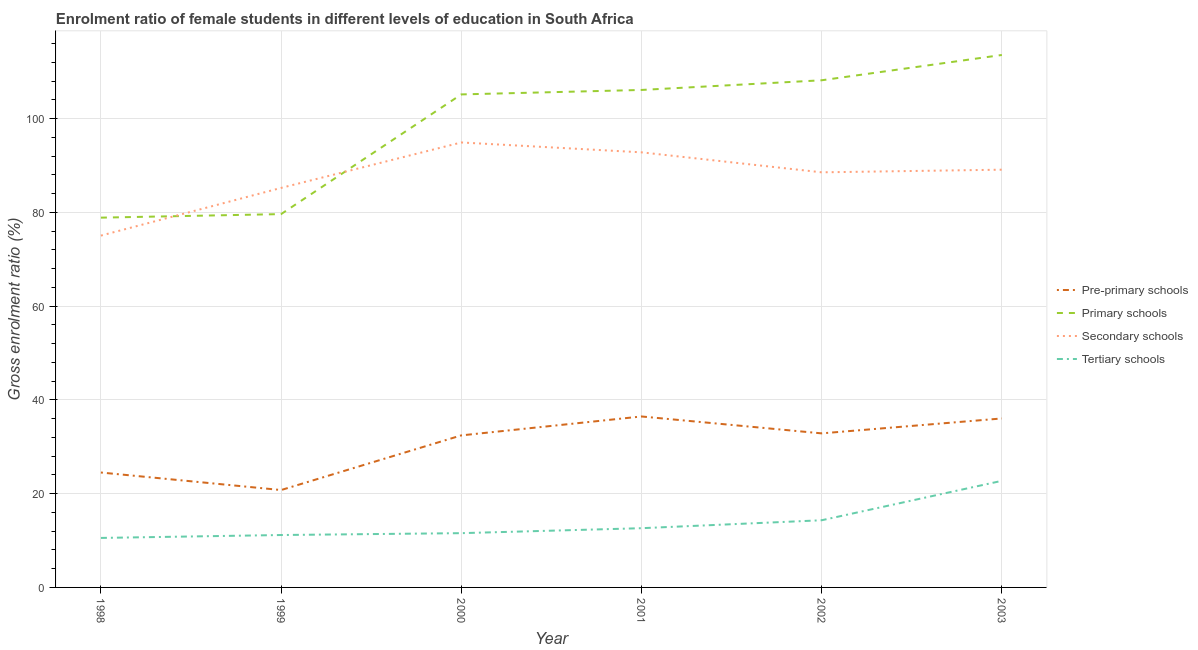How many different coloured lines are there?
Provide a short and direct response. 4. Does the line corresponding to gross enrolment ratio(male) in tertiary schools intersect with the line corresponding to gross enrolment ratio(male) in primary schools?
Give a very brief answer. No. Is the number of lines equal to the number of legend labels?
Provide a succinct answer. Yes. What is the gross enrolment ratio(male) in secondary schools in 2001?
Your answer should be very brief. 92.82. Across all years, what is the maximum gross enrolment ratio(male) in primary schools?
Your answer should be compact. 113.59. Across all years, what is the minimum gross enrolment ratio(male) in secondary schools?
Ensure brevity in your answer.  75.06. What is the total gross enrolment ratio(male) in pre-primary schools in the graph?
Keep it short and to the point. 183.11. What is the difference between the gross enrolment ratio(male) in tertiary schools in 1999 and that in 2001?
Keep it short and to the point. -1.46. What is the difference between the gross enrolment ratio(male) in secondary schools in 2002 and the gross enrolment ratio(male) in primary schools in 2003?
Your response must be concise. -25.04. What is the average gross enrolment ratio(male) in pre-primary schools per year?
Your response must be concise. 30.52. In the year 2002, what is the difference between the gross enrolment ratio(male) in secondary schools and gross enrolment ratio(male) in tertiary schools?
Offer a very short reply. 74.23. In how many years, is the gross enrolment ratio(male) in primary schools greater than 112 %?
Give a very brief answer. 1. What is the ratio of the gross enrolment ratio(male) in tertiary schools in 1998 to that in 2001?
Provide a succinct answer. 0.84. Is the gross enrolment ratio(male) in tertiary schools in 1998 less than that in 2000?
Ensure brevity in your answer.  Yes. Is the difference between the gross enrolment ratio(male) in pre-primary schools in 1999 and 2003 greater than the difference between the gross enrolment ratio(male) in secondary schools in 1999 and 2003?
Your answer should be very brief. No. What is the difference between the highest and the second highest gross enrolment ratio(male) in tertiary schools?
Offer a very short reply. 8.41. What is the difference between the highest and the lowest gross enrolment ratio(male) in pre-primary schools?
Give a very brief answer. 15.7. In how many years, is the gross enrolment ratio(male) in tertiary schools greater than the average gross enrolment ratio(male) in tertiary schools taken over all years?
Provide a short and direct response. 2. Does the gross enrolment ratio(male) in pre-primary schools monotonically increase over the years?
Offer a very short reply. No. Is the gross enrolment ratio(male) in pre-primary schools strictly less than the gross enrolment ratio(male) in secondary schools over the years?
Offer a terse response. Yes. How many lines are there?
Offer a very short reply. 4. Are the values on the major ticks of Y-axis written in scientific E-notation?
Make the answer very short. No. Does the graph contain grids?
Your response must be concise. Yes. Where does the legend appear in the graph?
Offer a terse response. Center right. How many legend labels are there?
Your answer should be very brief. 4. How are the legend labels stacked?
Your response must be concise. Vertical. What is the title of the graph?
Ensure brevity in your answer.  Enrolment ratio of female students in different levels of education in South Africa. What is the label or title of the X-axis?
Offer a very short reply. Year. What is the label or title of the Y-axis?
Ensure brevity in your answer.  Gross enrolment ratio (%). What is the Gross enrolment ratio (%) in Pre-primary schools in 1998?
Keep it short and to the point. 24.51. What is the Gross enrolment ratio (%) in Primary schools in 1998?
Make the answer very short. 78.89. What is the Gross enrolment ratio (%) of Secondary schools in 1998?
Offer a terse response. 75.06. What is the Gross enrolment ratio (%) of Tertiary schools in 1998?
Offer a very short reply. 10.56. What is the Gross enrolment ratio (%) of Pre-primary schools in 1999?
Give a very brief answer. 20.78. What is the Gross enrolment ratio (%) of Primary schools in 1999?
Ensure brevity in your answer.  79.64. What is the Gross enrolment ratio (%) in Secondary schools in 1999?
Your answer should be compact. 85.23. What is the Gross enrolment ratio (%) in Tertiary schools in 1999?
Offer a very short reply. 11.18. What is the Gross enrolment ratio (%) in Pre-primary schools in 2000?
Offer a terse response. 32.44. What is the Gross enrolment ratio (%) of Primary schools in 2000?
Make the answer very short. 105.18. What is the Gross enrolment ratio (%) of Secondary schools in 2000?
Provide a succinct answer. 94.93. What is the Gross enrolment ratio (%) of Tertiary schools in 2000?
Give a very brief answer. 11.58. What is the Gross enrolment ratio (%) of Pre-primary schools in 2001?
Give a very brief answer. 36.47. What is the Gross enrolment ratio (%) of Primary schools in 2001?
Your answer should be compact. 106.13. What is the Gross enrolment ratio (%) in Secondary schools in 2001?
Make the answer very short. 92.82. What is the Gross enrolment ratio (%) of Tertiary schools in 2001?
Make the answer very short. 12.64. What is the Gross enrolment ratio (%) of Pre-primary schools in 2002?
Offer a terse response. 32.87. What is the Gross enrolment ratio (%) in Primary schools in 2002?
Your answer should be very brief. 108.19. What is the Gross enrolment ratio (%) in Secondary schools in 2002?
Your answer should be very brief. 88.56. What is the Gross enrolment ratio (%) in Tertiary schools in 2002?
Provide a short and direct response. 14.33. What is the Gross enrolment ratio (%) of Pre-primary schools in 2003?
Make the answer very short. 36.05. What is the Gross enrolment ratio (%) in Primary schools in 2003?
Offer a terse response. 113.59. What is the Gross enrolment ratio (%) in Secondary schools in 2003?
Your answer should be compact. 89.12. What is the Gross enrolment ratio (%) in Tertiary schools in 2003?
Make the answer very short. 22.74. Across all years, what is the maximum Gross enrolment ratio (%) of Pre-primary schools?
Keep it short and to the point. 36.47. Across all years, what is the maximum Gross enrolment ratio (%) in Primary schools?
Offer a terse response. 113.59. Across all years, what is the maximum Gross enrolment ratio (%) in Secondary schools?
Ensure brevity in your answer.  94.93. Across all years, what is the maximum Gross enrolment ratio (%) in Tertiary schools?
Give a very brief answer. 22.74. Across all years, what is the minimum Gross enrolment ratio (%) of Pre-primary schools?
Offer a terse response. 20.78. Across all years, what is the minimum Gross enrolment ratio (%) in Primary schools?
Your answer should be compact. 78.89. Across all years, what is the minimum Gross enrolment ratio (%) in Secondary schools?
Make the answer very short. 75.06. Across all years, what is the minimum Gross enrolment ratio (%) of Tertiary schools?
Your answer should be compact. 10.56. What is the total Gross enrolment ratio (%) of Pre-primary schools in the graph?
Your answer should be very brief. 183.11. What is the total Gross enrolment ratio (%) in Primary schools in the graph?
Keep it short and to the point. 591.62. What is the total Gross enrolment ratio (%) of Secondary schools in the graph?
Give a very brief answer. 525.71. What is the total Gross enrolment ratio (%) in Tertiary schools in the graph?
Provide a short and direct response. 83.02. What is the difference between the Gross enrolment ratio (%) of Pre-primary schools in 1998 and that in 1999?
Your response must be concise. 3.74. What is the difference between the Gross enrolment ratio (%) in Primary schools in 1998 and that in 1999?
Offer a very short reply. -0.76. What is the difference between the Gross enrolment ratio (%) of Secondary schools in 1998 and that in 1999?
Provide a succinct answer. -10.17. What is the difference between the Gross enrolment ratio (%) in Tertiary schools in 1998 and that in 1999?
Give a very brief answer. -0.62. What is the difference between the Gross enrolment ratio (%) of Pre-primary schools in 1998 and that in 2000?
Keep it short and to the point. -7.92. What is the difference between the Gross enrolment ratio (%) of Primary schools in 1998 and that in 2000?
Give a very brief answer. -26.29. What is the difference between the Gross enrolment ratio (%) in Secondary schools in 1998 and that in 2000?
Your answer should be very brief. -19.87. What is the difference between the Gross enrolment ratio (%) of Tertiary schools in 1998 and that in 2000?
Make the answer very short. -1.02. What is the difference between the Gross enrolment ratio (%) of Pre-primary schools in 1998 and that in 2001?
Make the answer very short. -11.96. What is the difference between the Gross enrolment ratio (%) in Primary schools in 1998 and that in 2001?
Make the answer very short. -27.24. What is the difference between the Gross enrolment ratio (%) in Secondary schools in 1998 and that in 2001?
Your response must be concise. -17.76. What is the difference between the Gross enrolment ratio (%) in Tertiary schools in 1998 and that in 2001?
Your response must be concise. -2.08. What is the difference between the Gross enrolment ratio (%) in Pre-primary schools in 1998 and that in 2002?
Provide a succinct answer. -8.35. What is the difference between the Gross enrolment ratio (%) in Primary schools in 1998 and that in 2002?
Offer a terse response. -29.31. What is the difference between the Gross enrolment ratio (%) in Secondary schools in 1998 and that in 2002?
Offer a very short reply. -13.5. What is the difference between the Gross enrolment ratio (%) of Tertiary schools in 1998 and that in 2002?
Provide a short and direct response. -3.77. What is the difference between the Gross enrolment ratio (%) in Pre-primary schools in 1998 and that in 2003?
Your answer should be very brief. -11.53. What is the difference between the Gross enrolment ratio (%) of Primary schools in 1998 and that in 2003?
Offer a terse response. -34.7. What is the difference between the Gross enrolment ratio (%) of Secondary schools in 1998 and that in 2003?
Ensure brevity in your answer.  -14.06. What is the difference between the Gross enrolment ratio (%) in Tertiary schools in 1998 and that in 2003?
Your answer should be compact. -12.18. What is the difference between the Gross enrolment ratio (%) of Pre-primary schools in 1999 and that in 2000?
Keep it short and to the point. -11.66. What is the difference between the Gross enrolment ratio (%) in Primary schools in 1999 and that in 2000?
Your answer should be compact. -25.53. What is the difference between the Gross enrolment ratio (%) of Secondary schools in 1999 and that in 2000?
Your answer should be compact. -9.69. What is the difference between the Gross enrolment ratio (%) of Tertiary schools in 1999 and that in 2000?
Keep it short and to the point. -0.4. What is the difference between the Gross enrolment ratio (%) in Pre-primary schools in 1999 and that in 2001?
Provide a succinct answer. -15.7. What is the difference between the Gross enrolment ratio (%) of Primary schools in 1999 and that in 2001?
Your answer should be very brief. -26.49. What is the difference between the Gross enrolment ratio (%) in Secondary schools in 1999 and that in 2001?
Your answer should be very brief. -7.59. What is the difference between the Gross enrolment ratio (%) of Tertiary schools in 1999 and that in 2001?
Offer a terse response. -1.46. What is the difference between the Gross enrolment ratio (%) of Pre-primary schools in 1999 and that in 2002?
Keep it short and to the point. -12.09. What is the difference between the Gross enrolment ratio (%) of Primary schools in 1999 and that in 2002?
Provide a succinct answer. -28.55. What is the difference between the Gross enrolment ratio (%) in Secondary schools in 1999 and that in 2002?
Ensure brevity in your answer.  -3.32. What is the difference between the Gross enrolment ratio (%) in Tertiary schools in 1999 and that in 2002?
Your answer should be compact. -3.15. What is the difference between the Gross enrolment ratio (%) of Pre-primary schools in 1999 and that in 2003?
Give a very brief answer. -15.27. What is the difference between the Gross enrolment ratio (%) in Primary schools in 1999 and that in 2003?
Your answer should be compact. -33.95. What is the difference between the Gross enrolment ratio (%) of Secondary schools in 1999 and that in 2003?
Provide a succinct answer. -3.89. What is the difference between the Gross enrolment ratio (%) of Tertiary schools in 1999 and that in 2003?
Ensure brevity in your answer.  -11.56. What is the difference between the Gross enrolment ratio (%) of Pre-primary schools in 2000 and that in 2001?
Give a very brief answer. -4.03. What is the difference between the Gross enrolment ratio (%) in Primary schools in 2000 and that in 2001?
Offer a terse response. -0.95. What is the difference between the Gross enrolment ratio (%) of Secondary schools in 2000 and that in 2001?
Your answer should be compact. 2.1. What is the difference between the Gross enrolment ratio (%) in Tertiary schools in 2000 and that in 2001?
Your answer should be very brief. -1.06. What is the difference between the Gross enrolment ratio (%) in Pre-primary schools in 2000 and that in 2002?
Your answer should be very brief. -0.43. What is the difference between the Gross enrolment ratio (%) of Primary schools in 2000 and that in 2002?
Offer a terse response. -3.02. What is the difference between the Gross enrolment ratio (%) of Secondary schools in 2000 and that in 2002?
Offer a terse response. 6.37. What is the difference between the Gross enrolment ratio (%) in Tertiary schools in 2000 and that in 2002?
Provide a succinct answer. -2.75. What is the difference between the Gross enrolment ratio (%) in Pre-primary schools in 2000 and that in 2003?
Your answer should be very brief. -3.61. What is the difference between the Gross enrolment ratio (%) of Primary schools in 2000 and that in 2003?
Your response must be concise. -8.41. What is the difference between the Gross enrolment ratio (%) of Secondary schools in 2000 and that in 2003?
Make the answer very short. 5.81. What is the difference between the Gross enrolment ratio (%) in Tertiary schools in 2000 and that in 2003?
Your answer should be compact. -11.16. What is the difference between the Gross enrolment ratio (%) of Pre-primary schools in 2001 and that in 2002?
Your answer should be compact. 3.61. What is the difference between the Gross enrolment ratio (%) in Primary schools in 2001 and that in 2002?
Offer a very short reply. -2.06. What is the difference between the Gross enrolment ratio (%) in Secondary schools in 2001 and that in 2002?
Keep it short and to the point. 4.27. What is the difference between the Gross enrolment ratio (%) of Tertiary schools in 2001 and that in 2002?
Provide a short and direct response. -1.69. What is the difference between the Gross enrolment ratio (%) in Pre-primary schools in 2001 and that in 2003?
Ensure brevity in your answer.  0.42. What is the difference between the Gross enrolment ratio (%) of Primary schools in 2001 and that in 2003?
Your answer should be very brief. -7.46. What is the difference between the Gross enrolment ratio (%) of Secondary schools in 2001 and that in 2003?
Offer a very short reply. 3.7. What is the difference between the Gross enrolment ratio (%) in Tertiary schools in 2001 and that in 2003?
Provide a short and direct response. -10.11. What is the difference between the Gross enrolment ratio (%) in Pre-primary schools in 2002 and that in 2003?
Provide a short and direct response. -3.18. What is the difference between the Gross enrolment ratio (%) in Primary schools in 2002 and that in 2003?
Offer a terse response. -5.4. What is the difference between the Gross enrolment ratio (%) of Secondary schools in 2002 and that in 2003?
Keep it short and to the point. -0.56. What is the difference between the Gross enrolment ratio (%) in Tertiary schools in 2002 and that in 2003?
Your answer should be very brief. -8.41. What is the difference between the Gross enrolment ratio (%) in Pre-primary schools in 1998 and the Gross enrolment ratio (%) in Primary schools in 1999?
Make the answer very short. -55.13. What is the difference between the Gross enrolment ratio (%) in Pre-primary schools in 1998 and the Gross enrolment ratio (%) in Secondary schools in 1999?
Offer a very short reply. -60.72. What is the difference between the Gross enrolment ratio (%) in Pre-primary schools in 1998 and the Gross enrolment ratio (%) in Tertiary schools in 1999?
Keep it short and to the point. 13.33. What is the difference between the Gross enrolment ratio (%) in Primary schools in 1998 and the Gross enrolment ratio (%) in Secondary schools in 1999?
Give a very brief answer. -6.34. What is the difference between the Gross enrolment ratio (%) of Primary schools in 1998 and the Gross enrolment ratio (%) of Tertiary schools in 1999?
Keep it short and to the point. 67.71. What is the difference between the Gross enrolment ratio (%) in Secondary schools in 1998 and the Gross enrolment ratio (%) in Tertiary schools in 1999?
Offer a terse response. 63.88. What is the difference between the Gross enrolment ratio (%) in Pre-primary schools in 1998 and the Gross enrolment ratio (%) in Primary schools in 2000?
Provide a succinct answer. -80.66. What is the difference between the Gross enrolment ratio (%) of Pre-primary schools in 1998 and the Gross enrolment ratio (%) of Secondary schools in 2000?
Make the answer very short. -70.41. What is the difference between the Gross enrolment ratio (%) in Pre-primary schools in 1998 and the Gross enrolment ratio (%) in Tertiary schools in 2000?
Give a very brief answer. 12.94. What is the difference between the Gross enrolment ratio (%) in Primary schools in 1998 and the Gross enrolment ratio (%) in Secondary schools in 2000?
Make the answer very short. -16.04. What is the difference between the Gross enrolment ratio (%) in Primary schools in 1998 and the Gross enrolment ratio (%) in Tertiary schools in 2000?
Make the answer very short. 67.31. What is the difference between the Gross enrolment ratio (%) of Secondary schools in 1998 and the Gross enrolment ratio (%) of Tertiary schools in 2000?
Give a very brief answer. 63.48. What is the difference between the Gross enrolment ratio (%) of Pre-primary schools in 1998 and the Gross enrolment ratio (%) of Primary schools in 2001?
Offer a very short reply. -81.62. What is the difference between the Gross enrolment ratio (%) in Pre-primary schools in 1998 and the Gross enrolment ratio (%) in Secondary schools in 2001?
Keep it short and to the point. -68.31. What is the difference between the Gross enrolment ratio (%) in Pre-primary schools in 1998 and the Gross enrolment ratio (%) in Tertiary schools in 2001?
Your answer should be compact. 11.88. What is the difference between the Gross enrolment ratio (%) of Primary schools in 1998 and the Gross enrolment ratio (%) of Secondary schools in 2001?
Provide a short and direct response. -13.93. What is the difference between the Gross enrolment ratio (%) of Primary schools in 1998 and the Gross enrolment ratio (%) of Tertiary schools in 2001?
Provide a succinct answer. 66.25. What is the difference between the Gross enrolment ratio (%) in Secondary schools in 1998 and the Gross enrolment ratio (%) in Tertiary schools in 2001?
Offer a terse response. 62.42. What is the difference between the Gross enrolment ratio (%) in Pre-primary schools in 1998 and the Gross enrolment ratio (%) in Primary schools in 2002?
Give a very brief answer. -83.68. What is the difference between the Gross enrolment ratio (%) of Pre-primary schools in 1998 and the Gross enrolment ratio (%) of Secondary schools in 2002?
Offer a very short reply. -64.04. What is the difference between the Gross enrolment ratio (%) of Pre-primary schools in 1998 and the Gross enrolment ratio (%) of Tertiary schools in 2002?
Your answer should be compact. 10.18. What is the difference between the Gross enrolment ratio (%) in Primary schools in 1998 and the Gross enrolment ratio (%) in Secondary schools in 2002?
Provide a succinct answer. -9.67. What is the difference between the Gross enrolment ratio (%) of Primary schools in 1998 and the Gross enrolment ratio (%) of Tertiary schools in 2002?
Your answer should be compact. 64.56. What is the difference between the Gross enrolment ratio (%) of Secondary schools in 1998 and the Gross enrolment ratio (%) of Tertiary schools in 2002?
Offer a very short reply. 60.73. What is the difference between the Gross enrolment ratio (%) in Pre-primary schools in 1998 and the Gross enrolment ratio (%) in Primary schools in 2003?
Your answer should be compact. -89.08. What is the difference between the Gross enrolment ratio (%) of Pre-primary schools in 1998 and the Gross enrolment ratio (%) of Secondary schools in 2003?
Provide a short and direct response. -64.61. What is the difference between the Gross enrolment ratio (%) in Pre-primary schools in 1998 and the Gross enrolment ratio (%) in Tertiary schools in 2003?
Give a very brief answer. 1.77. What is the difference between the Gross enrolment ratio (%) in Primary schools in 1998 and the Gross enrolment ratio (%) in Secondary schools in 2003?
Your answer should be compact. -10.23. What is the difference between the Gross enrolment ratio (%) of Primary schools in 1998 and the Gross enrolment ratio (%) of Tertiary schools in 2003?
Ensure brevity in your answer.  56.15. What is the difference between the Gross enrolment ratio (%) in Secondary schools in 1998 and the Gross enrolment ratio (%) in Tertiary schools in 2003?
Offer a terse response. 52.31. What is the difference between the Gross enrolment ratio (%) in Pre-primary schools in 1999 and the Gross enrolment ratio (%) in Primary schools in 2000?
Offer a very short reply. -84.4. What is the difference between the Gross enrolment ratio (%) of Pre-primary schools in 1999 and the Gross enrolment ratio (%) of Secondary schools in 2000?
Offer a very short reply. -74.15. What is the difference between the Gross enrolment ratio (%) in Pre-primary schools in 1999 and the Gross enrolment ratio (%) in Tertiary schools in 2000?
Ensure brevity in your answer.  9.2. What is the difference between the Gross enrolment ratio (%) in Primary schools in 1999 and the Gross enrolment ratio (%) in Secondary schools in 2000?
Provide a succinct answer. -15.28. What is the difference between the Gross enrolment ratio (%) of Primary schools in 1999 and the Gross enrolment ratio (%) of Tertiary schools in 2000?
Provide a succinct answer. 68.07. What is the difference between the Gross enrolment ratio (%) in Secondary schools in 1999 and the Gross enrolment ratio (%) in Tertiary schools in 2000?
Make the answer very short. 73.65. What is the difference between the Gross enrolment ratio (%) in Pre-primary schools in 1999 and the Gross enrolment ratio (%) in Primary schools in 2001?
Offer a terse response. -85.35. What is the difference between the Gross enrolment ratio (%) in Pre-primary schools in 1999 and the Gross enrolment ratio (%) in Secondary schools in 2001?
Your answer should be very brief. -72.05. What is the difference between the Gross enrolment ratio (%) in Pre-primary schools in 1999 and the Gross enrolment ratio (%) in Tertiary schools in 2001?
Keep it short and to the point. 8.14. What is the difference between the Gross enrolment ratio (%) of Primary schools in 1999 and the Gross enrolment ratio (%) of Secondary schools in 2001?
Ensure brevity in your answer.  -13.18. What is the difference between the Gross enrolment ratio (%) in Primary schools in 1999 and the Gross enrolment ratio (%) in Tertiary schools in 2001?
Provide a succinct answer. 67.01. What is the difference between the Gross enrolment ratio (%) of Secondary schools in 1999 and the Gross enrolment ratio (%) of Tertiary schools in 2001?
Offer a very short reply. 72.6. What is the difference between the Gross enrolment ratio (%) of Pre-primary schools in 1999 and the Gross enrolment ratio (%) of Primary schools in 2002?
Your answer should be very brief. -87.42. What is the difference between the Gross enrolment ratio (%) in Pre-primary schools in 1999 and the Gross enrolment ratio (%) in Secondary schools in 2002?
Keep it short and to the point. -67.78. What is the difference between the Gross enrolment ratio (%) of Pre-primary schools in 1999 and the Gross enrolment ratio (%) of Tertiary schools in 2002?
Your answer should be very brief. 6.45. What is the difference between the Gross enrolment ratio (%) of Primary schools in 1999 and the Gross enrolment ratio (%) of Secondary schools in 2002?
Ensure brevity in your answer.  -8.91. What is the difference between the Gross enrolment ratio (%) in Primary schools in 1999 and the Gross enrolment ratio (%) in Tertiary schools in 2002?
Your response must be concise. 65.31. What is the difference between the Gross enrolment ratio (%) of Secondary schools in 1999 and the Gross enrolment ratio (%) of Tertiary schools in 2002?
Your response must be concise. 70.9. What is the difference between the Gross enrolment ratio (%) of Pre-primary schools in 1999 and the Gross enrolment ratio (%) of Primary schools in 2003?
Offer a very short reply. -92.82. What is the difference between the Gross enrolment ratio (%) of Pre-primary schools in 1999 and the Gross enrolment ratio (%) of Secondary schools in 2003?
Your answer should be very brief. -68.34. What is the difference between the Gross enrolment ratio (%) of Pre-primary schools in 1999 and the Gross enrolment ratio (%) of Tertiary schools in 2003?
Keep it short and to the point. -1.97. What is the difference between the Gross enrolment ratio (%) in Primary schools in 1999 and the Gross enrolment ratio (%) in Secondary schools in 2003?
Make the answer very short. -9.48. What is the difference between the Gross enrolment ratio (%) in Primary schools in 1999 and the Gross enrolment ratio (%) in Tertiary schools in 2003?
Your answer should be compact. 56.9. What is the difference between the Gross enrolment ratio (%) in Secondary schools in 1999 and the Gross enrolment ratio (%) in Tertiary schools in 2003?
Your answer should be very brief. 62.49. What is the difference between the Gross enrolment ratio (%) in Pre-primary schools in 2000 and the Gross enrolment ratio (%) in Primary schools in 2001?
Provide a succinct answer. -73.69. What is the difference between the Gross enrolment ratio (%) in Pre-primary schools in 2000 and the Gross enrolment ratio (%) in Secondary schools in 2001?
Provide a short and direct response. -60.38. What is the difference between the Gross enrolment ratio (%) of Pre-primary schools in 2000 and the Gross enrolment ratio (%) of Tertiary schools in 2001?
Give a very brief answer. 19.8. What is the difference between the Gross enrolment ratio (%) of Primary schools in 2000 and the Gross enrolment ratio (%) of Secondary schools in 2001?
Your response must be concise. 12.36. What is the difference between the Gross enrolment ratio (%) in Primary schools in 2000 and the Gross enrolment ratio (%) in Tertiary schools in 2001?
Provide a succinct answer. 92.54. What is the difference between the Gross enrolment ratio (%) in Secondary schools in 2000 and the Gross enrolment ratio (%) in Tertiary schools in 2001?
Your answer should be compact. 82.29. What is the difference between the Gross enrolment ratio (%) in Pre-primary schools in 2000 and the Gross enrolment ratio (%) in Primary schools in 2002?
Ensure brevity in your answer.  -75.76. What is the difference between the Gross enrolment ratio (%) in Pre-primary schools in 2000 and the Gross enrolment ratio (%) in Secondary schools in 2002?
Provide a succinct answer. -56.12. What is the difference between the Gross enrolment ratio (%) in Pre-primary schools in 2000 and the Gross enrolment ratio (%) in Tertiary schools in 2002?
Make the answer very short. 18.11. What is the difference between the Gross enrolment ratio (%) of Primary schools in 2000 and the Gross enrolment ratio (%) of Secondary schools in 2002?
Keep it short and to the point. 16.62. What is the difference between the Gross enrolment ratio (%) of Primary schools in 2000 and the Gross enrolment ratio (%) of Tertiary schools in 2002?
Give a very brief answer. 90.85. What is the difference between the Gross enrolment ratio (%) of Secondary schools in 2000 and the Gross enrolment ratio (%) of Tertiary schools in 2002?
Keep it short and to the point. 80.6. What is the difference between the Gross enrolment ratio (%) in Pre-primary schools in 2000 and the Gross enrolment ratio (%) in Primary schools in 2003?
Give a very brief answer. -81.15. What is the difference between the Gross enrolment ratio (%) in Pre-primary schools in 2000 and the Gross enrolment ratio (%) in Secondary schools in 2003?
Your response must be concise. -56.68. What is the difference between the Gross enrolment ratio (%) of Pre-primary schools in 2000 and the Gross enrolment ratio (%) of Tertiary schools in 2003?
Your answer should be compact. 9.69. What is the difference between the Gross enrolment ratio (%) of Primary schools in 2000 and the Gross enrolment ratio (%) of Secondary schools in 2003?
Offer a very short reply. 16.06. What is the difference between the Gross enrolment ratio (%) in Primary schools in 2000 and the Gross enrolment ratio (%) in Tertiary schools in 2003?
Offer a very short reply. 82.44. What is the difference between the Gross enrolment ratio (%) in Secondary schools in 2000 and the Gross enrolment ratio (%) in Tertiary schools in 2003?
Your response must be concise. 72.18. What is the difference between the Gross enrolment ratio (%) in Pre-primary schools in 2001 and the Gross enrolment ratio (%) in Primary schools in 2002?
Make the answer very short. -71.72. What is the difference between the Gross enrolment ratio (%) of Pre-primary schools in 2001 and the Gross enrolment ratio (%) of Secondary schools in 2002?
Your response must be concise. -52.08. What is the difference between the Gross enrolment ratio (%) of Pre-primary schools in 2001 and the Gross enrolment ratio (%) of Tertiary schools in 2002?
Provide a short and direct response. 22.14. What is the difference between the Gross enrolment ratio (%) of Primary schools in 2001 and the Gross enrolment ratio (%) of Secondary schools in 2002?
Make the answer very short. 17.57. What is the difference between the Gross enrolment ratio (%) of Primary schools in 2001 and the Gross enrolment ratio (%) of Tertiary schools in 2002?
Make the answer very short. 91.8. What is the difference between the Gross enrolment ratio (%) in Secondary schools in 2001 and the Gross enrolment ratio (%) in Tertiary schools in 2002?
Your response must be concise. 78.49. What is the difference between the Gross enrolment ratio (%) of Pre-primary schools in 2001 and the Gross enrolment ratio (%) of Primary schools in 2003?
Ensure brevity in your answer.  -77.12. What is the difference between the Gross enrolment ratio (%) in Pre-primary schools in 2001 and the Gross enrolment ratio (%) in Secondary schools in 2003?
Make the answer very short. -52.65. What is the difference between the Gross enrolment ratio (%) in Pre-primary schools in 2001 and the Gross enrolment ratio (%) in Tertiary schools in 2003?
Offer a very short reply. 13.73. What is the difference between the Gross enrolment ratio (%) in Primary schools in 2001 and the Gross enrolment ratio (%) in Secondary schools in 2003?
Your answer should be very brief. 17.01. What is the difference between the Gross enrolment ratio (%) in Primary schools in 2001 and the Gross enrolment ratio (%) in Tertiary schools in 2003?
Provide a short and direct response. 83.39. What is the difference between the Gross enrolment ratio (%) of Secondary schools in 2001 and the Gross enrolment ratio (%) of Tertiary schools in 2003?
Provide a succinct answer. 70.08. What is the difference between the Gross enrolment ratio (%) of Pre-primary schools in 2002 and the Gross enrolment ratio (%) of Primary schools in 2003?
Your answer should be compact. -80.73. What is the difference between the Gross enrolment ratio (%) of Pre-primary schools in 2002 and the Gross enrolment ratio (%) of Secondary schools in 2003?
Keep it short and to the point. -56.25. What is the difference between the Gross enrolment ratio (%) of Pre-primary schools in 2002 and the Gross enrolment ratio (%) of Tertiary schools in 2003?
Ensure brevity in your answer.  10.12. What is the difference between the Gross enrolment ratio (%) in Primary schools in 2002 and the Gross enrolment ratio (%) in Secondary schools in 2003?
Your answer should be very brief. 19.07. What is the difference between the Gross enrolment ratio (%) of Primary schools in 2002 and the Gross enrolment ratio (%) of Tertiary schools in 2003?
Provide a succinct answer. 85.45. What is the difference between the Gross enrolment ratio (%) of Secondary schools in 2002 and the Gross enrolment ratio (%) of Tertiary schools in 2003?
Provide a short and direct response. 65.81. What is the average Gross enrolment ratio (%) of Pre-primary schools per year?
Offer a terse response. 30.52. What is the average Gross enrolment ratio (%) in Primary schools per year?
Make the answer very short. 98.6. What is the average Gross enrolment ratio (%) of Secondary schools per year?
Make the answer very short. 87.62. What is the average Gross enrolment ratio (%) of Tertiary schools per year?
Offer a very short reply. 13.84. In the year 1998, what is the difference between the Gross enrolment ratio (%) in Pre-primary schools and Gross enrolment ratio (%) in Primary schools?
Provide a short and direct response. -54.37. In the year 1998, what is the difference between the Gross enrolment ratio (%) in Pre-primary schools and Gross enrolment ratio (%) in Secondary schools?
Make the answer very short. -50.54. In the year 1998, what is the difference between the Gross enrolment ratio (%) of Pre-primary schools and Gross enrolment ratio (%) of Tertiary schools?
Your response must be concise. 13.96. In the year 1998, what is the difference between the Gross enrolment ratio (%) of Primary schools and Gross enrolment ratio (%) of Secondary schools?
Your answer should be compact. 3.83. In the year 1998, what is the difference between the Gross enrolment ratio (%) of Primary schools and Gross enrolment ratio (%) of Tertiary schools?
Offer a terse response. 68.33. In the year 1998, what is the difference between the Gross enrolment ratio (%) of Secondary schools and Gross enrolment ratio (%) of Tertiary schools?
Give a very brief answer. 64.5. In the year 1999, what is the difference between the Gross enrolment ratio (%) in Pre-primary schools and Gross enrolment ratio (%) in Primary schools?
Provide a succinct answer. -58.87. In the year 1999, what is the difference between the Gross enrolment ratio (%) in Pre-primary schools and Gross enrolment ratio (%) in Secondary schools?
Your answer should be very brief. -64.46. In the year 1999, what is the difference between the Gross enrolment ratio (%) in Pre-primary schools and Gross enrolment ratio (%) in Tertiary schools?
Offer a terse response. 9.6. In the year 1999, what is the difference between the Gross enrolment ratio (%) of Primary schools and Gross enrolment ratio (%) of Secondary schools?
Make the answer very short. -5.59. In the year 1999, what is the difference between the Gross enrolment ratio (%) of Primary schools and Gross enrolment ratio (%) of Tertiary schools?
Your answer should be compact. 68.46. In the year 1999, what is the difference between the Gross enrolment ratio (%) in Secondary schools and Gross enrolment ratio (%) in Tertiary schools?
Make the answer very short. 74.05. In the year 2000, what is the difference between the Gross enrolment ratio (%) of Pre-primary schools and Gross enrolment ratio (%) of Primary schools?
Provide a short and direct response. -72.74. In the year 2000, what is the difference between the Gross enrolment ratio (%) in Pre-primary schools and Gross enrolment ratio (%) in Secondary schools?
Make the answer very short. -62.49. In the year 2000, what is the difference between the Gross enrolment ratio (%) of Pre-primary schools and Gross enrolment ratio (%) of Tertiary schools?
Make the answer very short. 20.86. In the year 2000, what is the difference between the Gross enrolment ratio (%) of Primary schools and Gross enrolment ratio (%) of Secondary schools?
Your response must be concise. 10.25. In the year 2000, what is the difference between the Gross enrolment ratio (%) of Primary schools and Gross enrolment ratio (%) of Tertiary schools?
Provide a short and direct response. 93.6. In the year 2000, what is the difference between the Gross enrolment ratio (%) of Secondary schools and Gross enrolment ratio (%) of Tertiary schools?
Provide a succinct answer. 83.35. In the year 2001, what is the difference between the Gross enrolment ratio (%) of Pre-primary schools and Gross enrolment ratio (%) of Primary schools?
Your answer should be compact. -69.66. In the year 2001, what is the difference between the Gross enrolment ratio (%) of Pre-primary schools and Gross enrolment ratio (%) of Secondary schools?
Your answer should be very brief. -56.35. In the year 2001, what is the difference between the Gross enrolment ratio (%) of Pre-primary schools and Gross enrolment ratio (%) of Tertiary schools?
Your answer should be compact. 23.84. In the year 2001, what is the difference between the Gross enrolment ratio (%) in Primary schools and Gross enrolment ratio (%) in Secondary schools?
Keep it short and to the point. 13.31. In the year 2001, what is the difference between the Gross enrolment ratio (%) in Primary schools and Gross enrolment ratio (%) in Tertiary schools?
Your answer should be very brief. 93.49. In the year 2001, what is the difference between the Gross enrolment ratio (%) of Secondary schools and Gross enrolment ratio (%) of Tertiary schools?
Offer a very short reply. 80.19. In the year 2002, what is the difference between the Gross enrolment ratio (%) in Pre-primary schools and Gross enrolment ratio (%) in Primary schools?
Offer a terse response. -75.33. In the year 2002, what is the difference between the Gross enrolment ratio (%) of Pre-primary schools and Gross enrolment ratio (%) of Secondary schools?
Give a very brief answer. -55.69. In the year 2002, what is the difference between the Gross enrolment ratio (%) in Pre-primary schools and Gross enrolment ratio (%) in Tertiary schools?
Give a very brief answer. 18.54. In the year 2002, what is the difference between the Gross enrolment ratio (%) of Primary schools and Gross enrolment ratio (%) of Secondary schools?
Keep it short and to the point. 19.64. In the year 2002, what is the difference between the Gross enrolment ratio (%) of Primary schools and Gross enrolment ratio (%) of Tertiary schools?
Keep it short and to the point. 93.86. In the year 2002, what is the difference between the Gross enrolment ratio (%) in Secondary schools and Gross enrolment ratio (%) in Tertiary schools?
Keep it short and to the point. 74.23. In the year 2003, what is the difference between the Gross enrolment ratio (%) in Pre-primary schools and Gross enrolment ratio (%) in Primary schools?
Your response must be concise. -77.54. In the year 2003, what is the difference between the Gross enrolment ratio (%) of Pre-primary schools and Gross enrolment ratio (%) of Secondary schools?
Offer a very short reply. -53.07. In the year 2003, what is the difference between the Gross enrolment ratio (%) in Pre-primary schools and Gross enrolment ratio (%) in Tertiary schools?
Your response must be concise. 13.31. In the year 2003, what is the difference between the Gross enrolment ratio (%) of Primary schools and Gross enrolment ratio (%) of Secondary schools?
Give a very brief answer. 24.47. In the year 2003, what is the difference between the Gross enrolment ratio (%) in Primary schools and Gross enrolment ratio (%) in Tertiary schools?
Offer a terse response. 90.85. In the year 2003, what is the difference between the Gross enrolment ratio (%) in Secondary schools and Gross enrolment ratio (%) in Tertiary schools?
Provide a succinct answer. 66.38. What is the ratio of the Gross enrolment ratio (%) in Pre-primary schools in 1998 to that in 1999?
Offer a very short reply. 1.18. What is the ratio of the Gross enrolment ratio (%) of Primary schools in 1998 to that in 1999?
Provide a succinct answer. 0.99. What is the ratio of the Gross enrolment ratio (%) in Secondary schools in 1998 to that in 1999?
Your answer should be compact. 0.88. What is the ratio of the Gross enrolment ratio (%) in Tertiary schools in 1998 to that in 1999?
Provide a short and direct response. 0.94. What is the ratio of the Gross enrolment ratio (%) in Pre-primary schools in 1998 to that in 2000?
Offer a very short reply. 0.76. What is the ratio of the Gross enrolment ratio (%) of Secondary schools in 1998 to that in 2000?
Offer a very short reply. 0.79. What is the ratio of the Gross enrolment ratio (%) in Tertiary schools in 1998 to that in 2000?
Ensure brevity in your answer.  0.91. What is the ratio of the Gross enrolment ratio (%) of Pre-primary schools in 1998 to that in 2001?
Make the answer very short. 0.67. What is the ratio of the Gross enrolment ratio (%) in Primary schools in 1998 to that in 2001?
Offer a very short reply. 0.74. What is the ratio of the Gross enrolment ratio (%) of Secondary schools in 1998 to that in 2001?
Give a very brief answer. 0.81. What is the ratio of the Gross enrolment ratio (%) of Tertiary schools in 1998 to that in 2001?
Your response must be concise. 0.84. What is the ratio of the Gross enrolment ratio (%) of Pre-primary schools in 1998 to that in 2002?
Ensure brevity in your answer.  0.75. What is the ratio of the Gross enrolment ratio (%) in Primary schools in 1998 to that in 2002?
Give a very brief answer. 0.73. What is the ratio of the Gross enrolment ratio (%) in Secondary schools in 1998 to that in 2002?
Provide a succinct answer. 0.85. What is the ratio of the Gross enrolment ratio (%) of Tertiary schools in 1998 to that in 2002?
Your response must be concise. 0.74. What is the ratio of the Gross enrolment ratio (%) of Pre-primary schools in 1998 to that in 2003?
Ensure brevity in your answer.  0.68. What is the ratio of the Gross enrolment ratio (%) of Primary schools in 1998 to that in 2003?
Your response must be concise. 0.69. What is the ratio of the Gross enrolment ratio (%) in Secondary schools in 1998 to that in 2003?
Provide a short and direct response. 0.84. What is the ratio of the Gross enrolment ratio (%) of Tertiary schools in 1998 to that in 2003?
Offer a very short reply. 0.46. What is the ratio of the Gross enrolment ratio (%) of Pre-primary schools in 1999 to that in 2000?
Provide a short and direct response. 0.64. What is the ratio of the Gross enrolment ratio (%) of Primary schools in 1999 to that in 2000?
Offer a very short reply. 0.76. What is the ratio of the Gross enrolment ratio (%) of Secondary schools in 1999 to that in 2000?
Make the answer very short. 0.9. What is the ratio of the Gross enrolment ratio (%) in Tertiary schools in 1999 to that in 2000?
Your response must be concise. 0.97. What is the ratio of the Gross enrolment ratio (%) in Pre-primary schools in 1999 to that in 2001?
Keep it short and to the point. 0.57. What is the ratio of the Gross enrolment ratio (%) in Primary schools in 1999 to that in 2001?
Provide a short and direct response. 0.75. What is the ratio of the Gross enrolment ratio (%) in Secondary schools in 1999 to that in 2001?
Your answer should be very brief. 0.92. What is the ratio of the Gross enrolment ratio (%) in Tertiary schools in 1999 to that in 2001?
Provide a short and direct response. 0.88. What is the ratio of the Gross enrolment ratio (%) in Pre-primary schools in 1999 to that in 2002?
Your answer should be very brief. 0.63. What is the ratio of the Gross enrolment ratio (%) in Primary schools in 1999 to that in 2002?
Keep it short and to the point. 0.74. What is the ratio of the Gross enrolment ratio (%) in Secondary schools in 1999 to that in 2002?
Provide a short and direct response. 0.96. What is the ratio of the Gross enrolment ratio (%) of Tertiary schools in 1999 to that in 2002?
Make the answer very short. 0.78. What is the ratio of the Gross enrolment ratio (%) of Pre-primary schools in 1999 to that in 2003?
Your answer should be very brief. 0.58. What is the ratio of the Gross enrolment ratio (%) in Primary schools in 1999 to that in 2003?
Keep it short and to the point. 0.7. What is the ratio of the Gross enrolment ratio (%) in Secondary schools in 1999 to that in 2003?
Offer a very short reply. 0.96. What is the ratio of the Gross enrolment ratio (%) of Tertiary schools in 1999 to that in 2003?
Make the answer very short. 0.49. What is the ratio of the Gross enrolment ratio (%) of Pre-primary schools in 2000 to that in 2001?
Provide a succinct answer. 0.89. What is the ratio of the Gross enrolment ratio (%) in Secondary schools in 2000 to that in 2001?
Offer a very short reply. 1.02. What is the ratio of the Gross enrolment ratio (%) of Tertiary schools in 2000 to that in 2001?
Ensure brevity in your answer.  0.92. What is the ratio of the Gross enrolment ratio (%) in Primary schools in 2000 to that in 2002?
Offer a terse response. 0.97. What is the ratio of the Gross enrolment ratio (%) in Secondary schools in 2000 to that in 2002?
Offer a terse response. 1.07. What is the ratio of the Gross enrolment ratio (%) of Tertiary schools in 2000 to that in 2002?
Ensure brevity in your answer.  0.81. What is the ratio of the Gross enrolment ratio (%) of Pre-primary schools in 2000 to that in 2003?
Make the answer very short. 0.9. What is the ratio of the Gross enrolment ratio (%) of Primary schools in 2000 to that in 2003?
Provide a short and direct response. 0.93. What is the ratio of the Gross enrolment ratio (%) of Secondary schools in 2000 to that in 2003?
Give a very brief answer. 1.07. What is the ratio of the Gross enrolment ratio (%) of Tertiary schools in 2000 to that in 2003?
Make the answer very short. 0.51. What is the ratio of the Gross enrolment ratio (%) of Pre-primary schools in 2001 to that in 2002?
Keep it short and to the point. 1.11. What is the ratio of the Gross enrolment ratio (%) of Primary schools in 2001 to that in 2002?
Offer a terse response. 0.98. What is the ratio of the Gross enrolment ratio (%) in Secondary schools in 2001 to that in 2002?
Your answer should be very brief. 1.05. What is the ratio of the Gross enrolment ratio (%) in Tertiary schools in 2001 to that in 2002?
Offer a terse response. 0.88. What is the ratio of the Gross enrolment ratio (%) in Pre-primary schools in 2001 to that in 2003?
Give a very brief answer. 1.01. What is the ratio of the Gross enrolment ratio (%) in Primary schools in 2001 to that in 2003?
Offer a terse response. 0.93. What is the ratio of the Gross enrolment ratio (%) in Secondary schools in 2001 to that in 2003?
Offer a terse response. 1.04. What is the ratio of the Gross enrolment ratio (%) in Tertiary schools in 2001 to that in 2003?
Your response must be concise. 0.56. What is the ratio of the Gross enrolment ratio (%) in Pre-primary schools in 2002 to that in 2003?
Provide a short and direct response. 0.91. What is the ratio of the Gross enrolment ratio (%) in Primary schools in 2002 to that in 2003?
Offer a terse response. 0.95. What is the ratio of the Gross enrolment ratio (%) in Tertiary schools in 2002 to that in 2003?
Offer a very short reply. 0.63. What is the difference between the highest and the second highest Gross enrolment ratio (%) of Pre-primary schools?
Make the answer very short. 0.42. What is the difference between the highest and the second highest Gross enrolment ratio (%) in Primary schools?
Your answer should be very brief. 5.4. What is the difference between the highest and the second highest Gross enrolment ratio (%) of Secondary schools?
Make the answer very short. 2.1. What is the difference between the highest and the second highest Gross enrolment ratio (%) in Tertiary schools?
Offer a very short reply. 8.41. What is the difference between the highest and the lowest Gross enrolment ratio (%) in Pre-primary schools?
Make the answer very short. 15.7. What is the difference between the highest and the lowest Gross enrolment ratio (%) of Primary schools?
Your answer should be compact. 34.7. What is the difference between the highest and the lowest Gross enrolment ratio (%) in Secondary schools?
Keep it short and to the point. 19.87. What is the difference between the highest and the lowest Gross enrolment ratio (%) in Tertiary schools?
Your answer should be very brief. 12.18. 